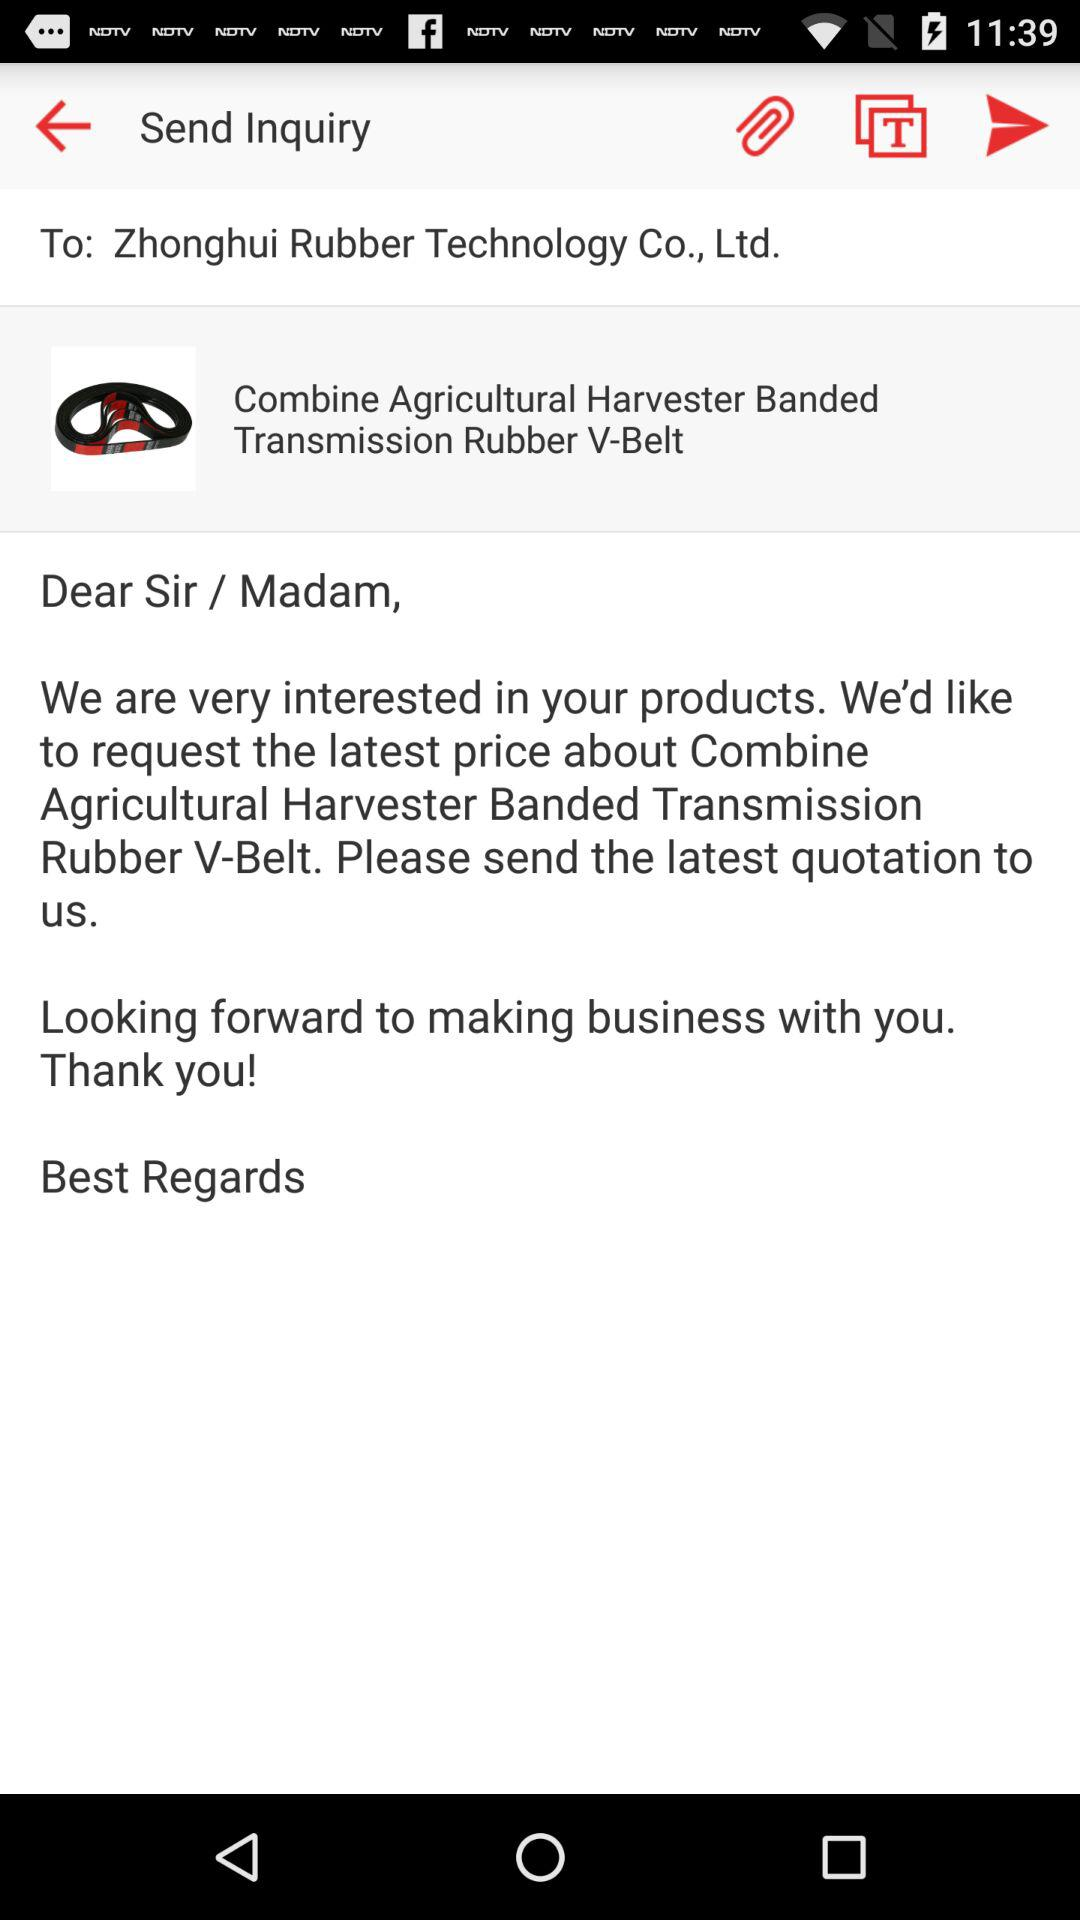To which company am I sending the mail? You are sending the mail to "Zhonghui Rubber Technology Co., Ltd.". 